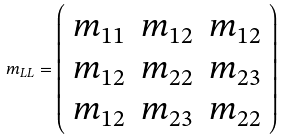<formula> <loc_0><loc_0><loc_500><loc_500>m _ { L L } = \left ( \begin{array} { c c c } m _ { 1 1 } & m _ { 1 2 } & m _ { 1 2 } \\ m _ { 1 2 } & m _ { 2 2 } & m _ { 2 3 } \\ m _ { 1 2 } & m _ { 2 3 } & m _ { 2 2 } \end{array} \right )</formula> 